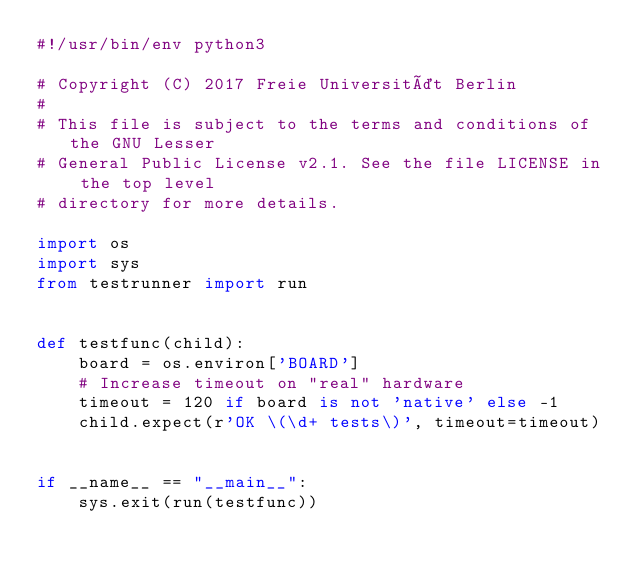<code> <loc_0><loc_0><loc_500><loc_500><_Python_>#!/usr/bin/env python3

# Copyright (C) 2017 Freie Universität Berlin
#
# This file is subject to the terms and conditions of the GNU Lesser
# General Public License v2.1. See the file LICENSE in the top level
# directory for more details.

import os
import sys
from testrunner import run


def testfunc(child):
    board = os.environ['BOARD']
    # Increase timeout on "real" hardware
    timeout = 120 if board is not 'native' else -1
    child.expect(r'OK \(\d+ tests\)', timeout=timeout)


if __name__ == "__main__":
    sys.exit(run(testfunc))
</code> 